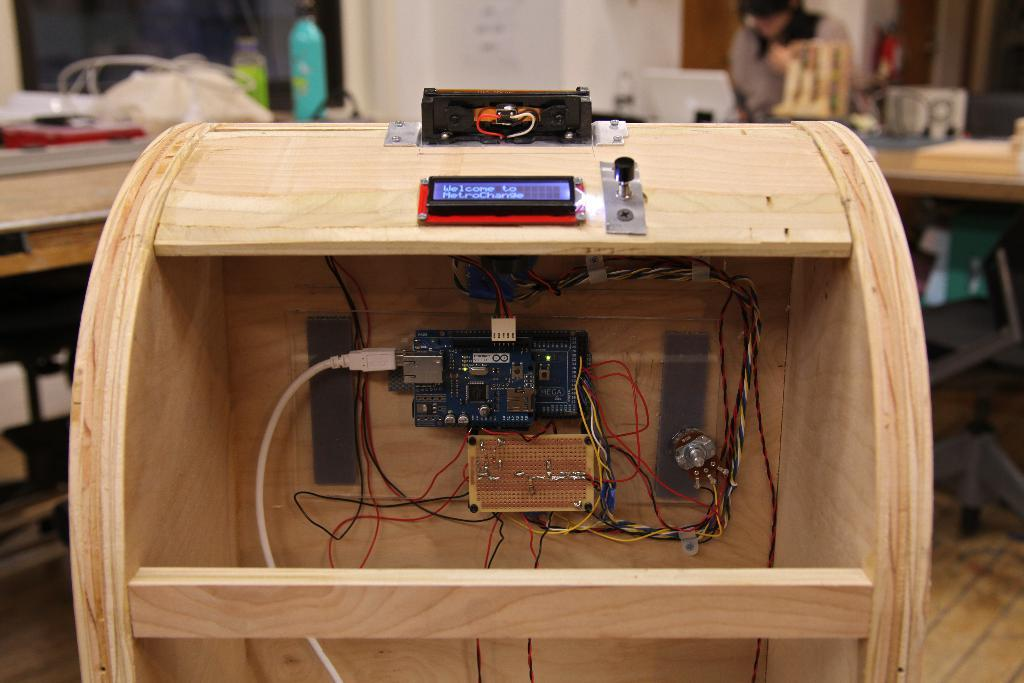What object is the main focus of the image? There is a wooden box in the image. What can be found inside the wooden box? There are electrical items inside the wooden box. Can you describe the background of the image? The background of the image is blurred. How is the glue being used in the image? There is no glue present in the image. What type of control is being used to operate the carriage in the image? There is no carriage present in the image. 